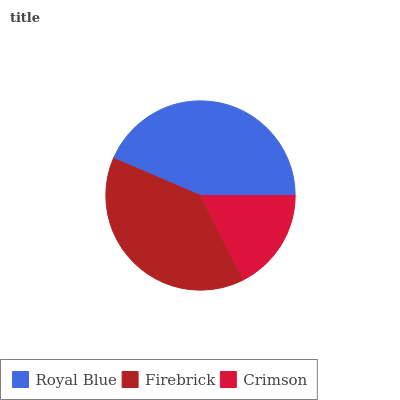Is Crimson the minimum?
Answer yes or no. Yes. Is Royal Blue the maximum?
Answer yes or no. Yes. Is Firebrick the minimum?
Answer yes or no. No. Is Firebrick the maximum?
Answer yes or no. No. Is Royal Blue greater than Firebrick?
Answer yes or no. Yes. Is Firebrick less than Royal Blue?
Answer yes or no. Yes. Is Firebrick greater than Royal Blue?
Answer yes or no. No. Is Royal Blue less than Firebrick?
Answer yes or no. No. Is Firebrick the high median?
Answer yes or no. Yes. Is Firebrick the low median?
Answer yes or no. Yes. Is Royal Blue the high median?
Answer yes or no. No. Is Crimson the low median?
Answer yes or no. No. 